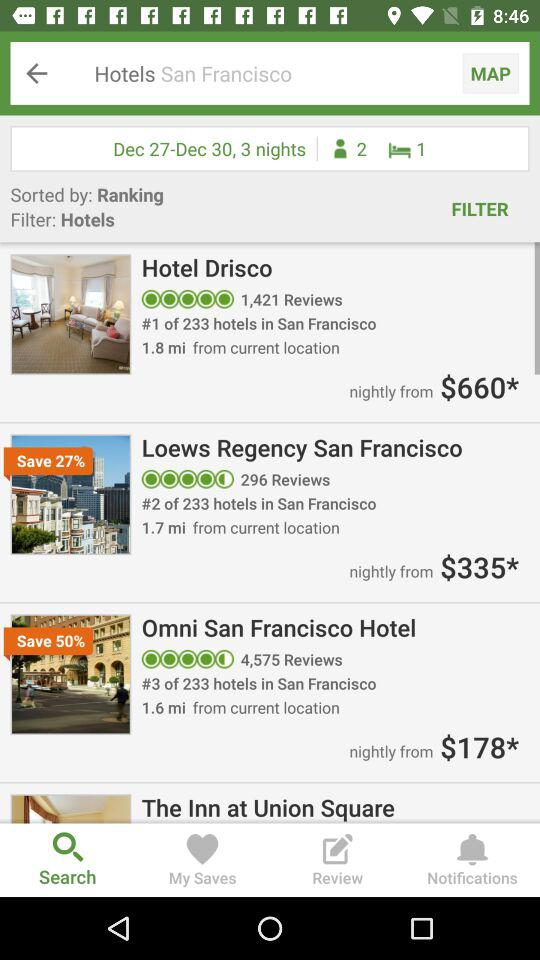What are the different options available to continue with? The different options available to continue with "Google", "Facebook" and "email address". 